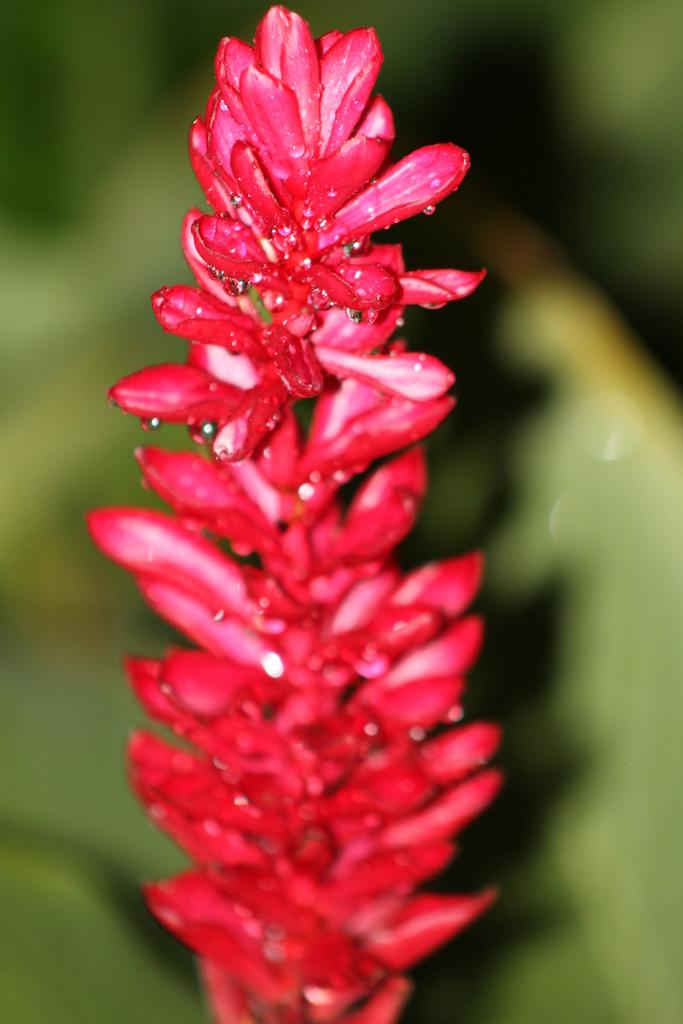What type of flower is in the image? There is a pink flower in the image. Can you describe the condition of the flower? The flower has water droplets on it. What type of corn can be seen growing in the ocean near the flower? There is no corn or ocean present in the image; it only features a pink flower with water droplets on it. 